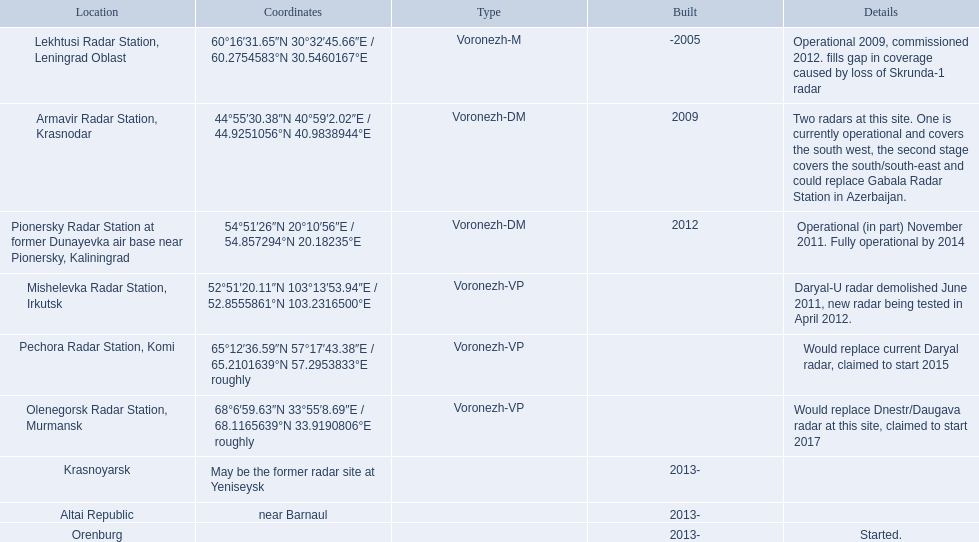What are all the positionings? Lekhtusi Radar Station, Leningrad Oblast, Armavir Radar Station, Krasnodar, Pionersky Radar Station at former Dunayevka air base near Pionersky, Kaliningrad, Mishelevka Radar Station, Irkutsk, Pechora Radar Station, Komi, Olenegorsk Radar Station, Murmansk, Krasnoyarsk, Altai Republic, Orenburg. And which positioning's coordinates are 60deg16'31.65''n 30deg32'45.66''e / 60.2754583degn 30.5460167dege? Lekhtusi Radar Station, Leningrad Oblast. 